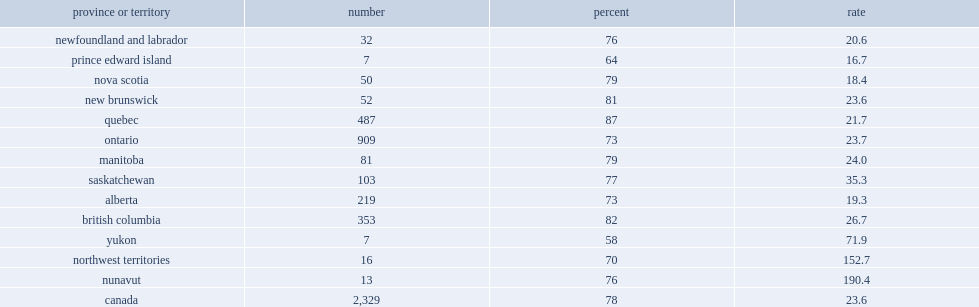Give me the full table as a dictionary. {'header': ['province or territory', 'number', 'percent', 'rate'], 'rows': [['newfoundland and labrador', '32', '76', '20.6'], ['prince edward island', '7', '64', '16.7'], ['nova scotia', '50', '79', '18.4'], ['new brunswick', '52', '81', '23.6'], ['quebec', '487', '87', '21.7'], ['ontario', '909', '73', '23.7'], ['manitoba', '81', '79', '24.0'], ['saskatchewan', '103', '77', '35.3'], ['alberta', '219', '73', '19.3'], ['british columbia', '353', '82', '26.7'], ['yukon', '7', '58', '71.9'], ['northwest territories', '16', '70', '152.7'], ['nunavut', '13', '76', '190.4'], ['canada', '2,329', '78', '23.6']]} In canada, how many women in shelters have dentified their abuser as a current or former spouse or common-law partner? 2329.0. In canada, how many percent of women in shelters have identified their abuser as a current or former spouse or common-law partner? 78.0. 